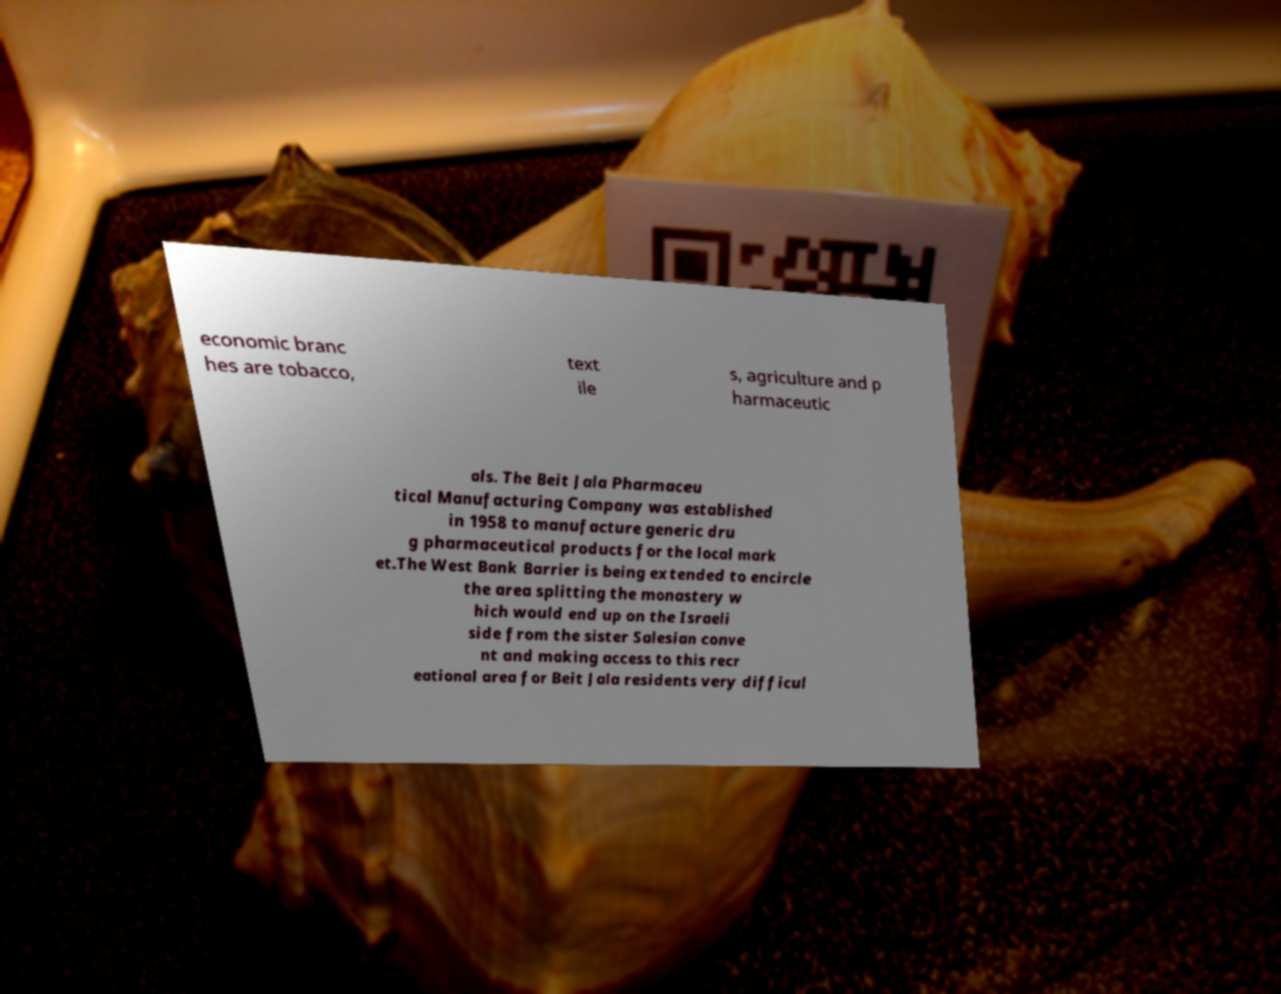Could you extract and type out the text from this image? economic branc hes are tobacco, text ile s, agriculture and p harmaceutic als. The Beit Jala Pharmaceu tical Manufacturing Company was established in 1958 to manufacture generic dru g pharmaceutical products for the local mark et.The West Bank Barrier is being extended to encircle the area splitting the monastery w hich would end up on the Israeli side from the sister Salesian conve nt and making access to this recr eational area for Beit Jala residents very difficul 